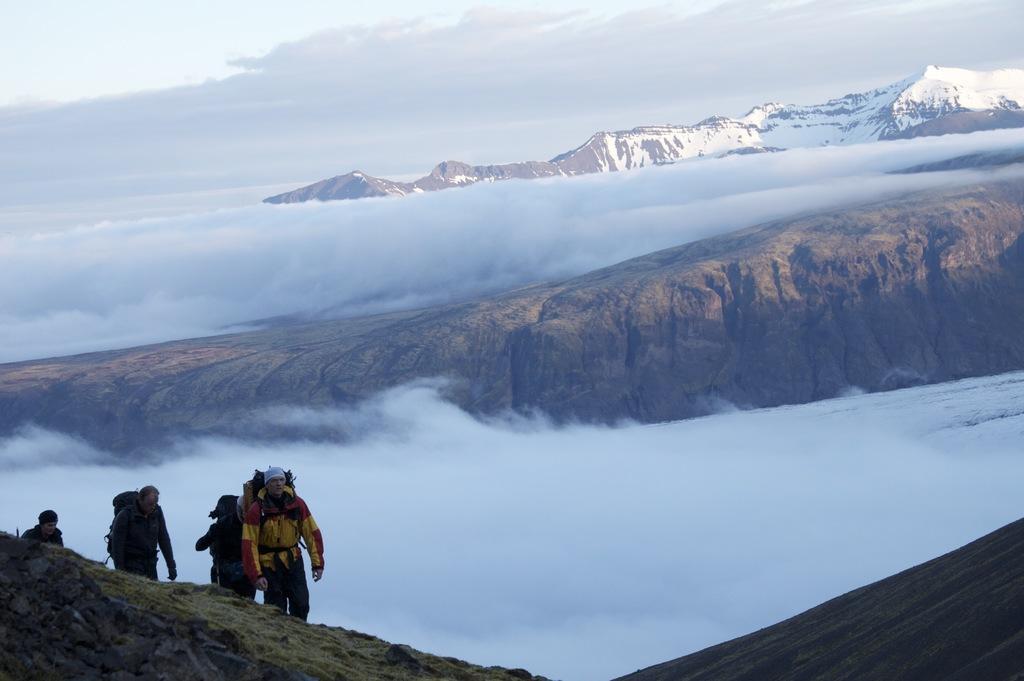Please provide a concise description of this image. This picture shows Hills and rocks and few people climbing and they wore backpacks on their back. 